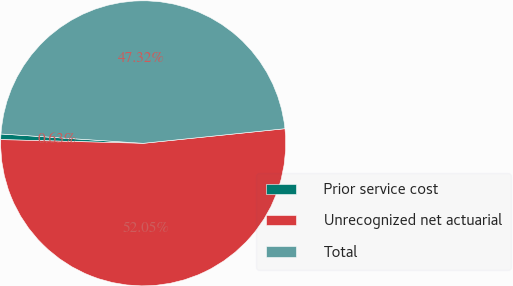Convert chart to OTSL. <chart><loc_0><loc_0><loc_500><loc_500><pie_chart><fcel>Prior service cost<fcel>Unrecognized net actuarial<fcel>Total<nl><fcel>0.63%<fcel>52.05%<fcel>47.32%<nl></chart> 